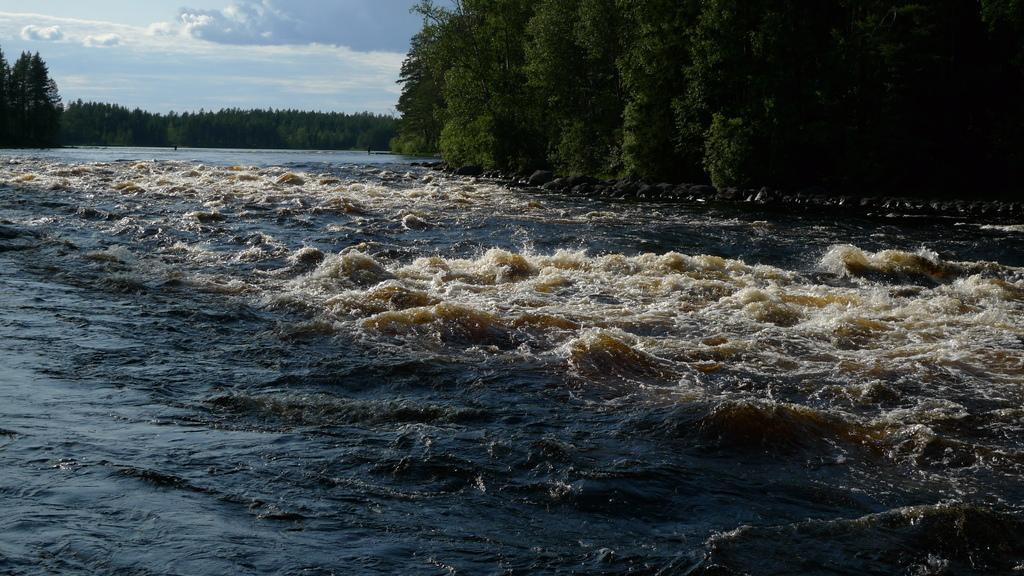What type of natural feature is depicted in the image? There is a river in the image. What can be seen near the river? Trees are present near the river. What part of the sky is visible in the image? The sky is visible in the top left of the image. What type of poison is being used by the manager in the image? There is no manager or poison present in the image. How many horses are visible in the image? There are no horses present in the image. 